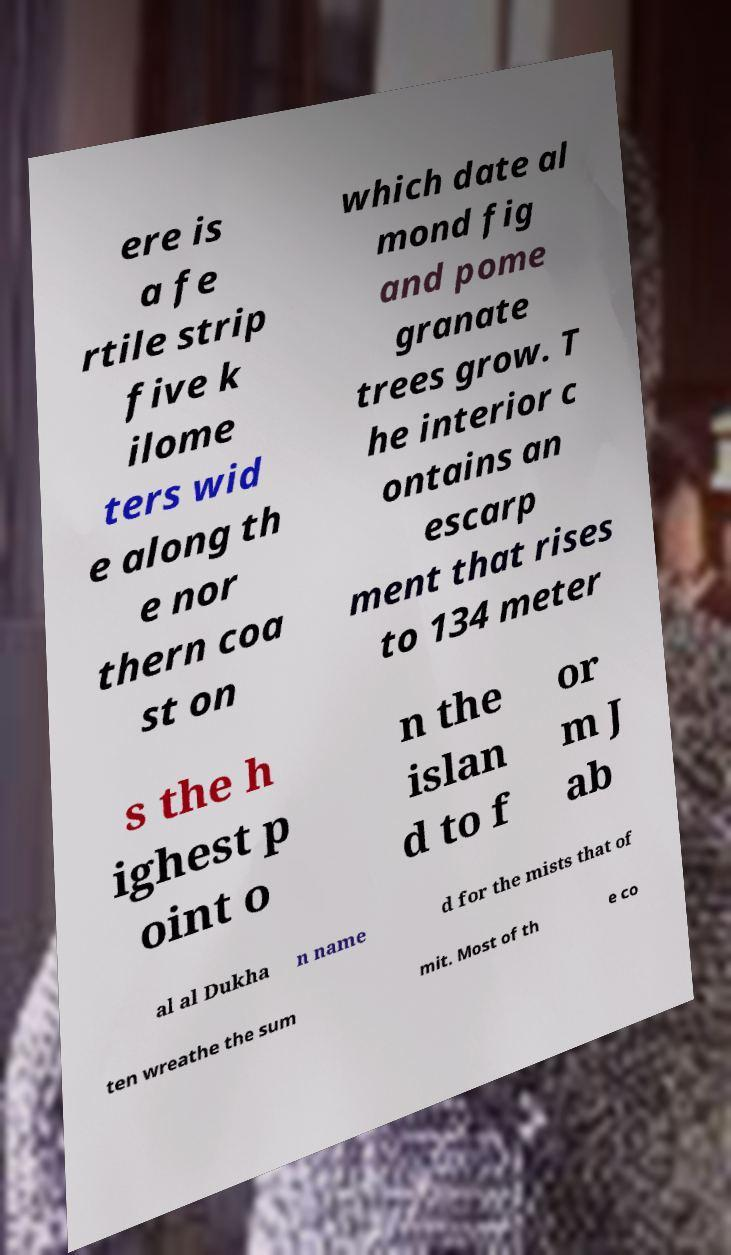Could you extract and type out the text from this image? ere is a fe rtile strip five k ilome ters wid e along th e nor thern coa st on which date al mond fig and pome granate trees grow. T he interior c ontains an escarp ment that rises to 134 meter s the h ighest p oint o n the islan d to f or m J ab al al Dukha n name d for the mists that of ten wreathe the sum mit. Most of th e co 